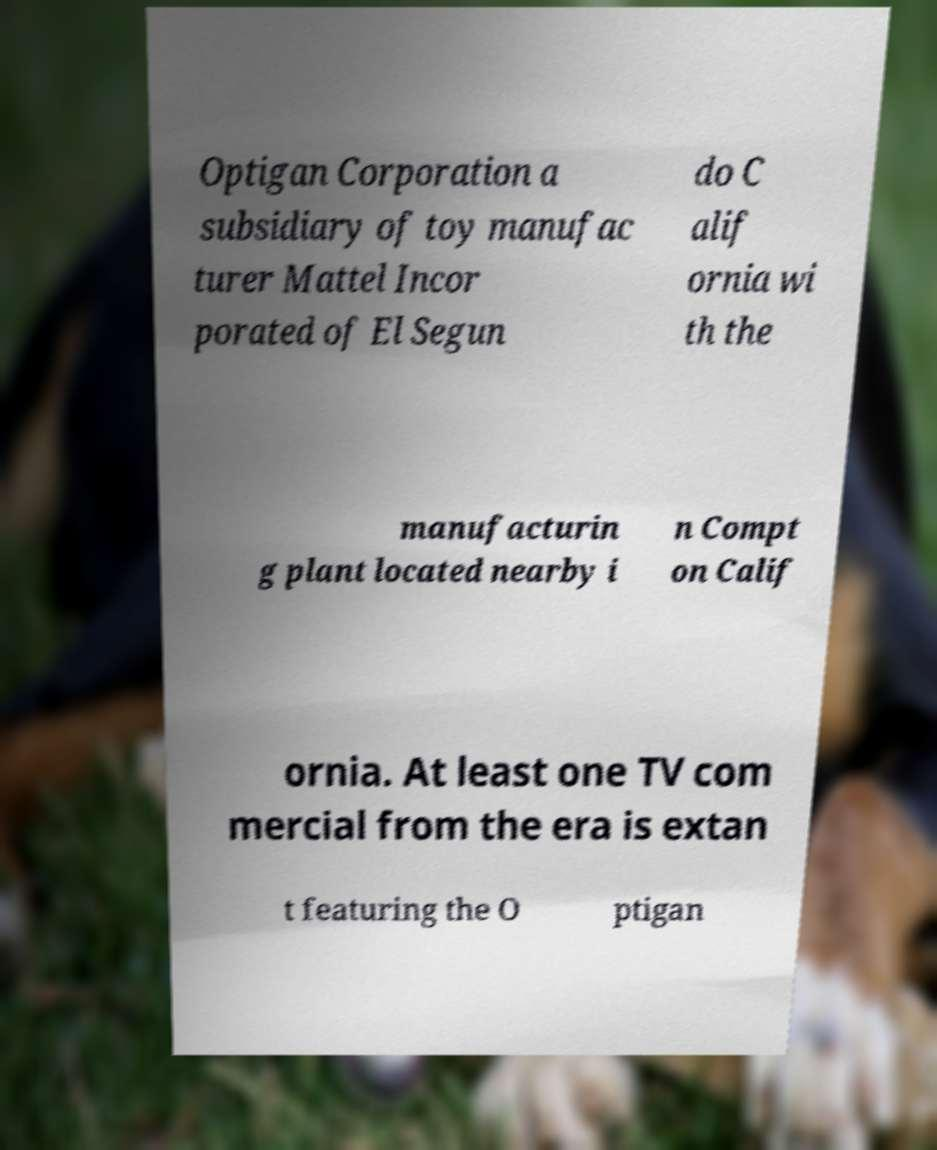Can you read and provide the text displayed in the image?This photo seems to have some interesting text. Can you extract and type it out for me? Optigan Corporation a subsidiary of toy manufac turer Mattel Incor porated of El Segun do C alif ornia wi th the manufacturin g plant located nearby i n Compt on Calif ornia. At least one TV com mercial from the era is extan t featuring the O ptigan 